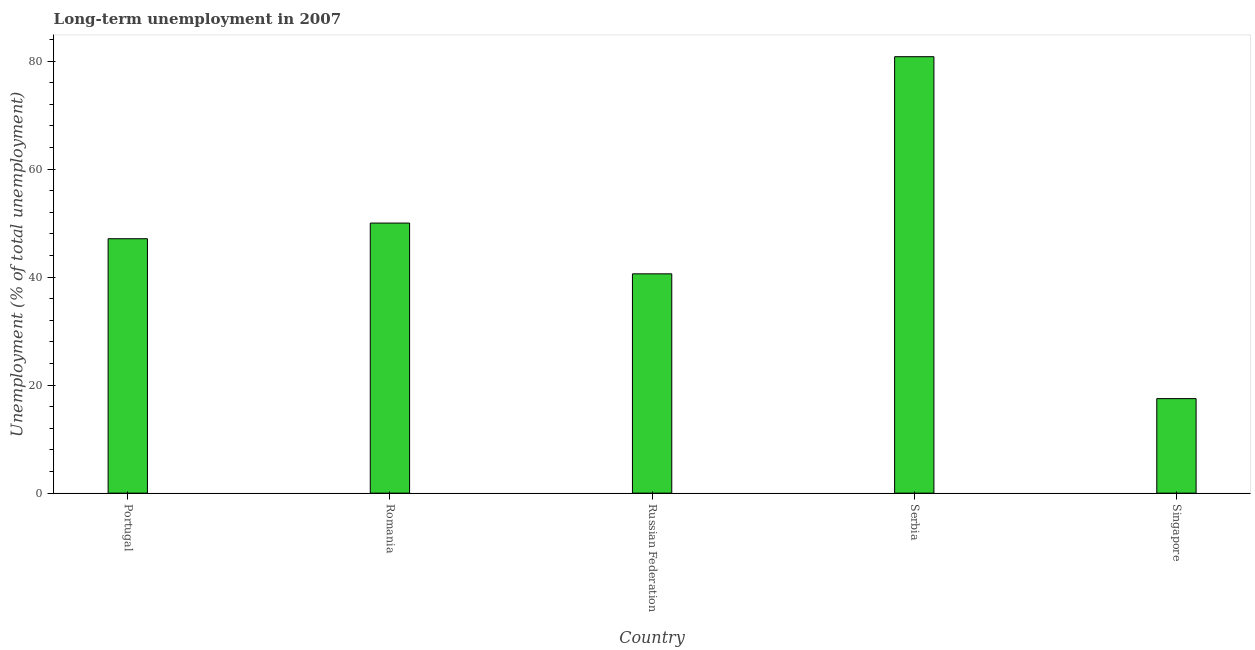What is the title of the graph?
Your response must be concise. Long-term unemployment in 2007. What is the label or title of the Y-axis?
Your answer should be very brief. Unemployment (% of total unemployment). What is the long-term unemployment in Romania?
Give a very brief answer. 50. Across all countries, what is the maximum long-term unemployment?
Provide a short and direct response. 80.8. Across all countries, what is the minimum long-term unemployment?
Make the answer very short. 17.5. In which country was the long-term unemployment maximum?
Offer a very short reply. Serbia. In which country was the long-term unemployment minimum?
Offer a very short reply. Singapore. What is the sum of the long-term unemployment?
Offer a terse response. 236. What is the average long-term unemployment per country?
Give a very brief answer. 47.2. What is the median long-term unemployment?
Give a very brief answer. 47.1. In how many countries, is the long-term unemployment greater than 56 %?
Give a very brief answer. 1. What is the ratio of the long-term unemployment in Romania to that in Singapore?
Your answer should be very brief. 2.86. Is the long-term unemployment in Portugal less than that in Romania?
Your answer should be very brief. Yes. Is the difference between the long-term unemployment in Russian Federation and Serbia greater than the difference between any two countries?
Your answer should be very brief. No. What is the difference between the highest and the second highest long-term unemployment?
Provide a succinct answer. 30.8. What is the difference between the highest and the lowest long-term unemployment?
Your response must be concise. 63.3. In how many countries, is the long-term unemployment greater than the average long-term unemployment taken over all countries?
Give a very brief answer. 2. What is the difference between two consecutive major ticks on the Y-axis?
Offer a very short reply. 20. Are the values on the major ticks of Y-axis written in scientific E-notation?
Keep it short and to the point. No. What is the Unemployment (% of total unemployment) in Portugal?
Ensure brevity in your answer.  47.1. What is the Unemployment (% of total unemployment) of Russian Federation?
Your response must be concise. 40.6. What is the Unemployment (% of total unemployment) of Serbia?
Provide a short and direct response. 80.8. What is the difference between the Unemployment (% of total unemployment) in Portugal and Romania?
Ensure brevity in your answer.  -2.9. What is the difference between the Unemployment (% of total unemployment) in Portugal and Serbia?
Your answer should be very brief. -33.7. What is the difference between the Unemployment (% of total unemployment) in Portugal and Singapore?
Keep it short and to the point. 29.6. What is the difference between the Unemployment (% of total unemployment) in Romania and Serbia?
Offer a very short reply. -30.8. What is the difference between the Unemployment (% of total unemployment) in Romania and Singapore?
Offer a terse response. 32.5. What is the difference between the Unemployment (% of total unemployment) in Russian Federation and Serbia?
Give a very brief answer. -40.2. What is the difference between the Unemployment (% of total unemployment) in Russian Federation and Singapore?
Provide a succinct answer. 23.1. What is the difference between the Unemployment (% of total unemployment) in Serbia and Singapore?
Ensure brevity in your answer.  63.3. What is the ratio of the Unemployment (% of total unemployment) in Portugal to that in Romania?
Your answer should be very brief. 0.94. What is the ratio of the Unemployment (% of total unemployment) in Portugal to that in Russian Federation?
Provide a succinct answer. 1.16. What is the ratio of the Unemployment (% of total unemployment) in Portugal to that in Serbia?
Offer a very short reply. 0.58. What is the ratio of the Unemployment (% of total unemployment) in Portugal to that in Singapore?
Keep it short and to the point. 2.69. What is the ratio of the Unemployment (% of total unemployment) in Romania to that in Russian Federation?
Offer a very short reply. 1.23. What is the ratio of the Unemployment (% of total unemployment) in Romania to that in Serbia?
Keep it short and to the point. 0.62. What is the ratio of the Unemployment (% of total unemployment) in Romania to that in Singapore?
Offer a terse response. 2.86. What is the ratio of the Unemployment (% of total unemployment) in Russian Federation to that in Serbia?
Offer a very short reply. 0.5. What is the ratio of the Unemployment (% of total unemployment) in Russian Federation to that in Singapore?
Provide a short and direct response. 2.32. What is the ratio of the Unemployment (% of total unemployment) in Serbia to that in Singapore?
Provide a succinct answer. 4.62. 